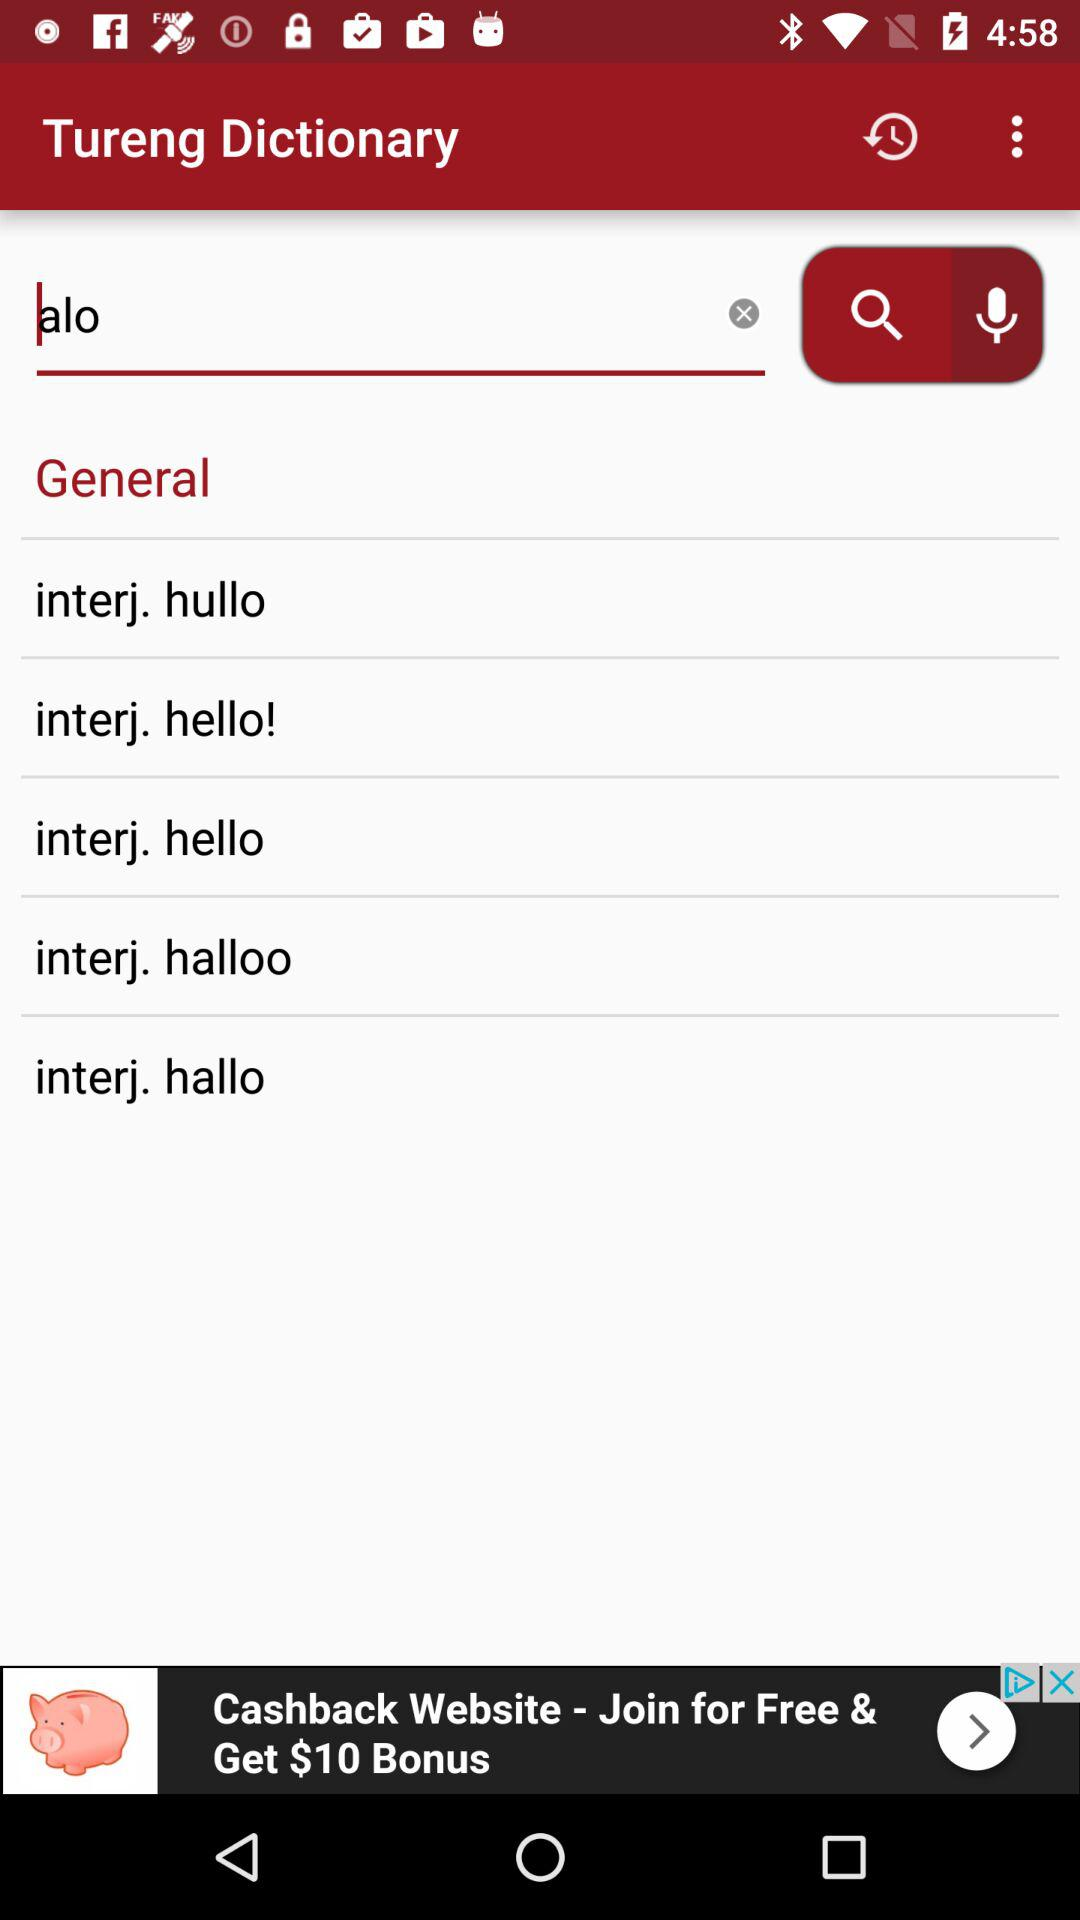What is the name of the application? The name of the application is "Tureng Dictionary". 